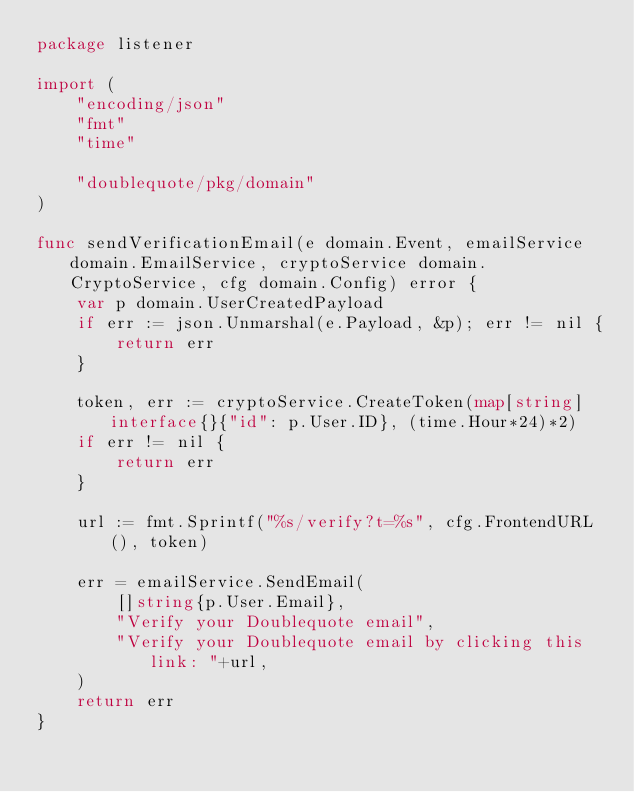<code> <loc_0><loc_0><loc_500><loc_500><_Go_>package listener

import (
	"encoding/json"
	"fmt"
	"time"

	"doublequote/pkg/domain"
)

func sendVerificationEmail(e domain.Event, emailService domain.EmailService, cryptoService domain.CryptoService, cfg domain.Config) error {
	var p domain.UserCreatedPayload
	if err := json.Unmarshal(e.Payload, &p); err != nil {
		return err
	}

	token, err := cryptoService.CreateToken(map[string]interface{}{"id": p.User.ID}, (time.Hour*24)*2)
	if err != nil {
		return err
	}

	url := fmt.Sprintf("%s/verify?t=%s", cfg.FrontendURL(), token)

	err = emailService.SendEmail(
		[]string{p.User.Email},
		"Verify your Doublequote email",
		"Verify your Doublequote email by clicking this link: "+url,
	)
	return err
}
</code> 